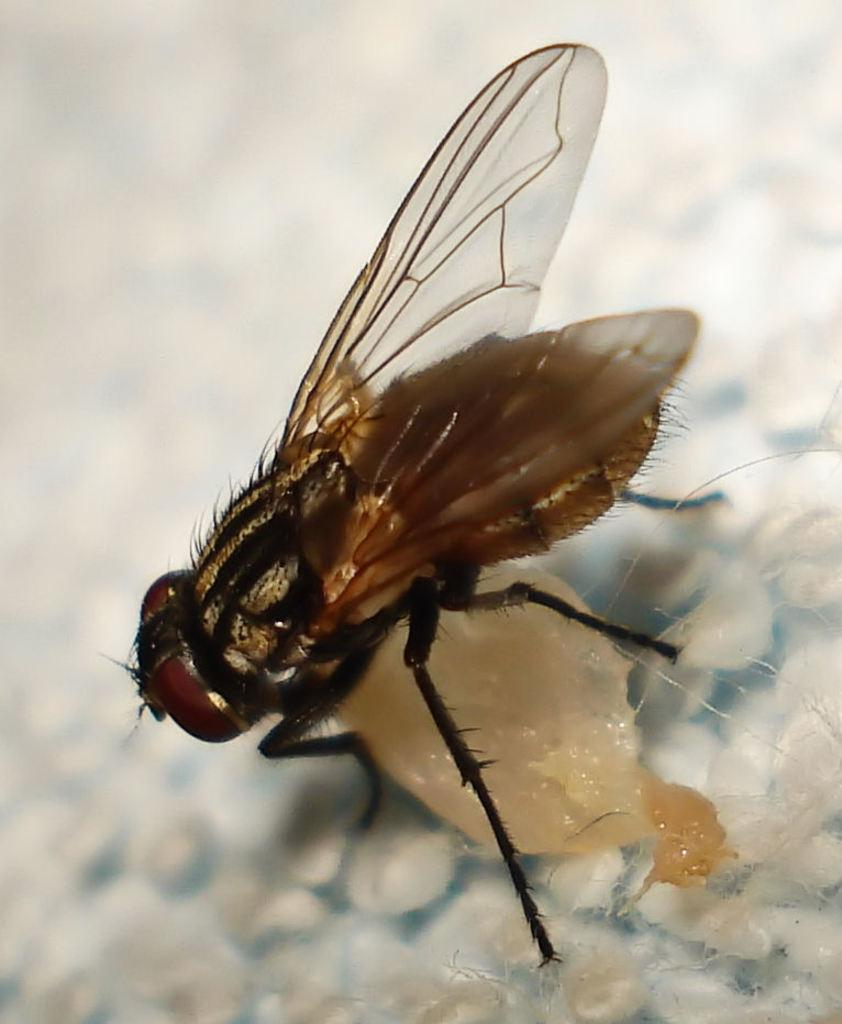What type of creature is in the image? There is an insect in the image. What colors can be seen on the insect? The insect has brown and black colors. What color is the background of the image? The background of the image is white. What type of rock is the insect standing on in the image? There is no rock present in the image; it features an insect on a white background. 